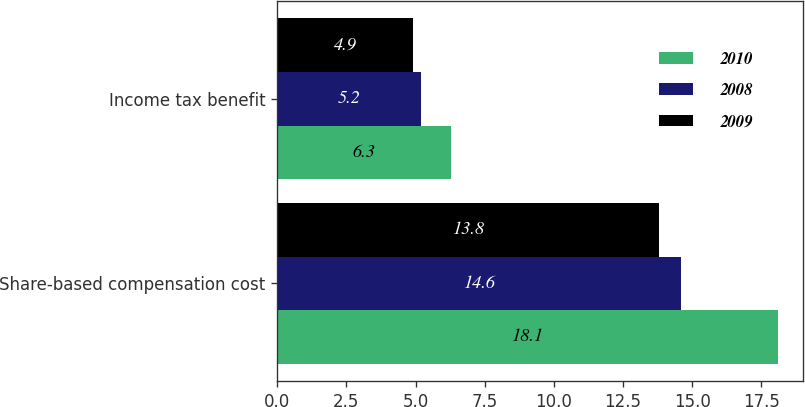Convert chart. <chart><loc_0><loc_0><loc_500><loc_500><stacked_bar_chart><ecel><fcel>Share-based compensation cost<fcel>Income tax benefit<nl><fcel>2010<fcel>18.1<fcel>6.3<nl><fcel>2008<fcel>14.6<fcel>5.2<nl><fcel>2009<fcel>13.8<fcel>4.9<nl></chart> 